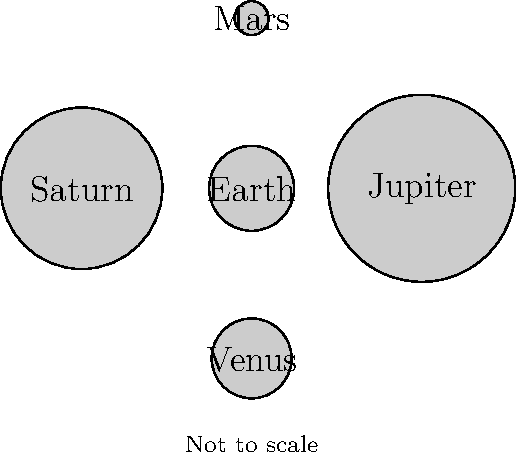As an urban farmer considering greenhouse materials, understanding scale is crucial. In the solar system, which planet shown in the diagram is closest in size to Earth, and how might this knowledge influence your greenhouse design choices? To answer this question, let's analyze the relative sizes of the planets shown in the diagram:

1. Earth is represented by a circle with a radius of 0.5 units.
2. Jupiter has a radius of 1.1 units, making it much larger than Earth.
3. Saturn has a radius of 0.95 units, also significantly larger than Earth.
4. Mars has a radius of 0.2 units, making it much smaller than Earth.
5. Venus has a radius of 0.47 units, which is the closest to Earth's size.

Venus is the planet closest in size to Earth among those shown. In reality, Venus has about 95% of Earth's diameter.

This knowledge can influence greenhouse design choices in several ways:

1. Scale consideration: Understanding planetary sizes helps in appreciating the importance of scale in design. Just as Venus and Earth are similar in size but have vastly different environments, small changes in greenhouse design can have significant impacts.

2. Material efficiency: Venus's similarity in size to Earth might remind us of the importance of efficient use of materials. In greenhouse construction, using materials in proportion to the structure's size and needs is crucial for sustainability.

3. Climate control: Venus has an extreme greenhouse effect, which, while not desirable for Earth, demonstrates the power of heat-trapping materials. This could inspire the use of efficient insulating materials in greenhouse design to maintain optimal growing conditions while minimizing energy use.

4. Adaptability: The variety of planetary sizes shown emphasizes the need for adaptable designs. Your greenhouse should be flexible enough to accommodate different plant sizes and growing conditions, just as different planets support various environments.
Answer: Venus; inspires efficient material use and climate control in greenhouse design. 